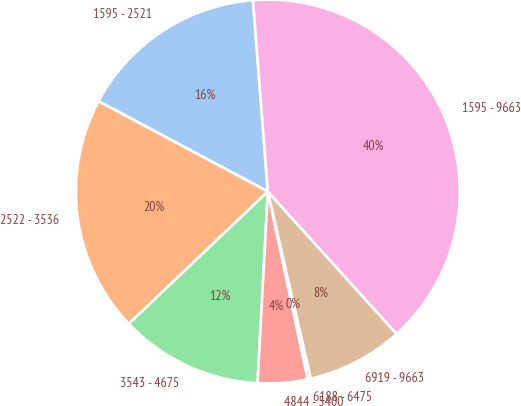<chart> <loc_0><loc_0><loc_500><loc_500><pie_chart><fcel>1595 - 2521<fcel>2522 - 3536<fcel>3543 - 4675<fcel>4844 - 5400<fcel>6188 - 6475<fcel>6919 - 9663<fcel>1595 - 9663<nl><fcel>15.97%<fcel>19.9%<fcel>12.04%<fcel>4.19%<fcel>0.26%<fcel>8.11%<fcel>39.53%<nl></chart> 